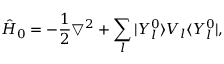Convert formula to latex. <formula><loc_0><loc_0><loc_500><loc_500>\hat { H } _ { 0 } = - \frac { 1 } { 2 } \bigtriangledown ^ { 2 } + \sum _ { l } | Y _ { l } ^ { 0 } \rangle V _ { l } \langle Y _ { l } ^ { 0 } | ,</formula> 